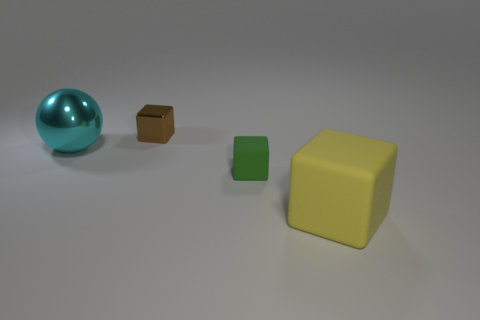Add 3 big yellow rubber objects. How many objects exist? 7 Subtract all cubes. How many objects are left? 1 Subtract 1 brown blocks. How many objects are left? 3 Subtract all tiny gray balls. Subtract all big shiny objects. How many objects are left? 3 Add 4 tiny things. How many tiny things are left? 6 Add 2 small things. How many small things exist? 4 